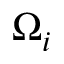Convert formula to latex. <formula><loc_0><loc_0><loc_500><loc_500>\Omega _ { i }</formula> 